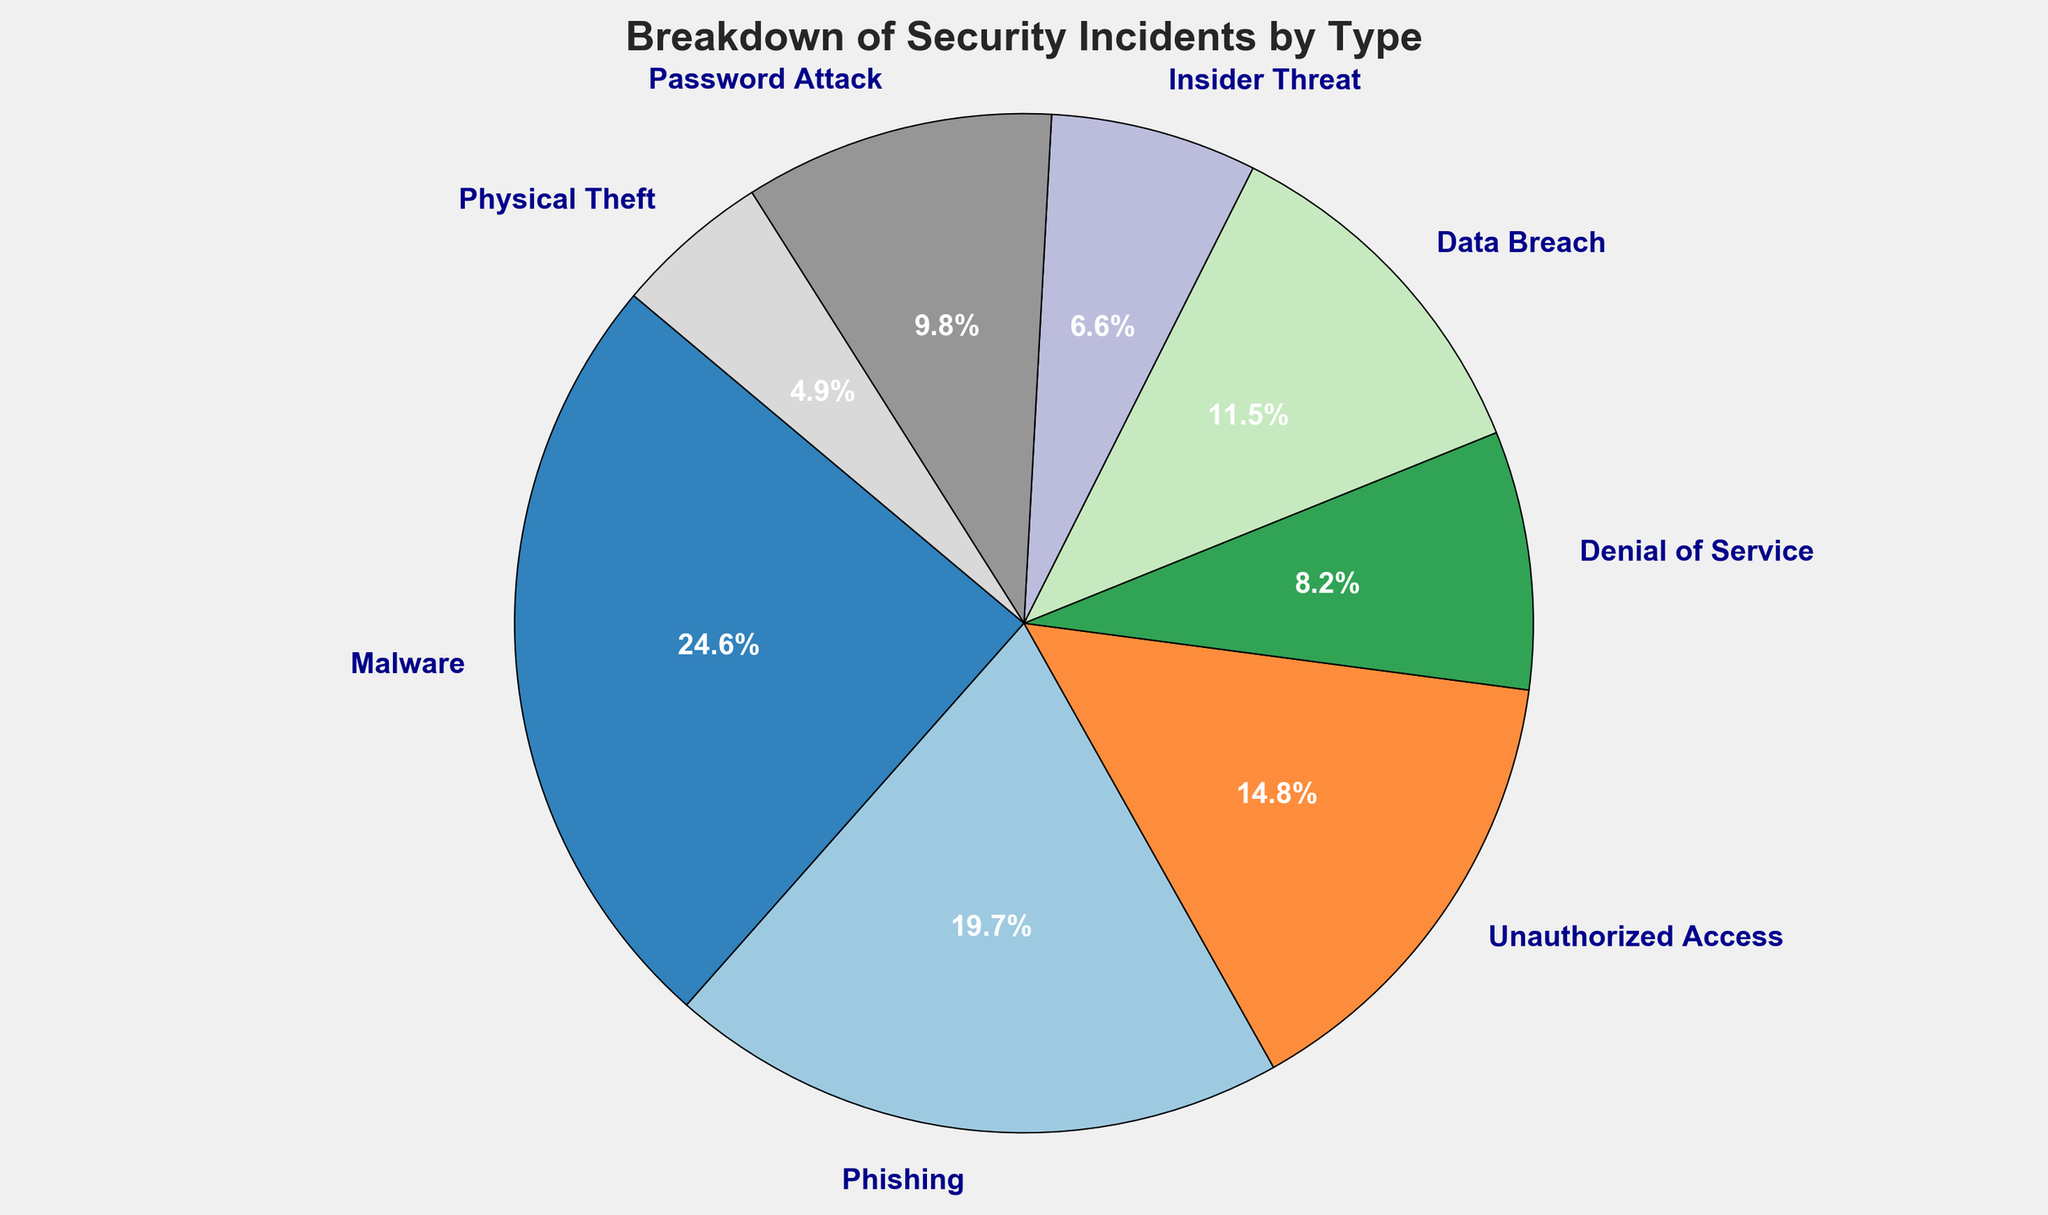What is the percentage of incidents attributed to Malware? To find the percentage of incidents attributed to Malware, look at the segment of the pie chart labeled "Malware" and note the percentage displayed.
Answer: 30.0% Which type of security incident is the least common? Identify the smallest segment of the pie chart and read the label. The smallest segment corresponds to the least common incident.
Answer: Physical Theft How does the number of Phishing incidents compare to Data Breaches? Look at the size of the segments corresponding to Phishing and Data Breaches. The percentage of Phishing incidents is higher, indicating more incidents.
Answer: More What is the combined percentage of Unauthorized Access, Data Breaches, and Insider Threats? To find the combined percentage, add the percentages of Unauthorized Access, Data Breaches, and Insider Threats from the pie chart (18.0% for Unauthorized Access, 14.0% for Data Breaches, and 8.0% for Insider Threats).
Answer: 40.0% If we combine Malware and Phishing incidents, what percentage of the total does this represent? Combine the percentages for Malware and Phishing by adding them together (30.0% for Malware and 24.0% for Phishing).
Answer: 54.0% Which segment on the pie chart represents Unauthorized Access, and what is its color? Examine the pie chart to find the segment labeled Unauthorized Access and note its color.
Answer: A segment labeled Unauthorized Access, likely in a specific color like green or blue Is the percentage of Denial of Service incidents greater than that of Physical Theft? Compare the percentages of Denial of Service (10.0%) with Physical Theft (6.0%). Denial of Service has a higher percentage.
Answer: Yes 